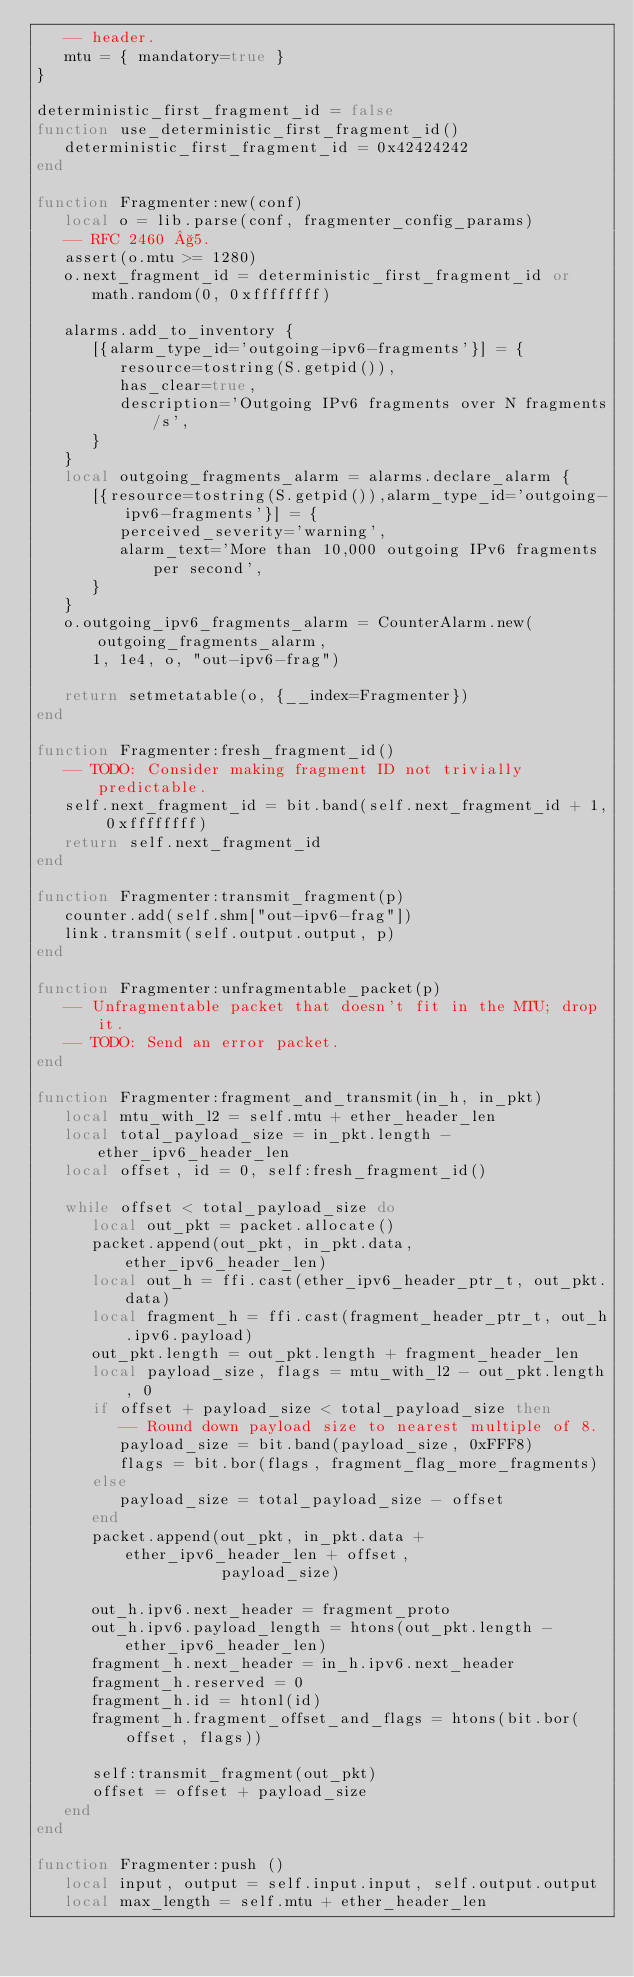<code> <loc_0><loc_0><loc_500><loc_500><_Lua_>   -- header.
   mtu = { mandatory=true }
}

deterministic_first_fragment_id = false
function use_deterministic_first_fragment_id()
   deterministic_first_fragment_id = 0x42424242
end

function Fragmenter:new(conf)
   local o = lib.parse(conf, fragmenter_config_params)
   -- RFC 2460 §5.
   assert(o.mtu >= 1280)
   o.next_fragment_id = deterministic_first_fragment_id or
      math.random(0, 0xffffffff)

   alarms.add_to_inventory {
      [{alarm_type_id='outgoing-ipv6-fragments'}] = {
         resource=tostring(S.getpid()),
         has_clear=true,
         description='Outgoing IPv6 fragments over N fragments/s',
      }
   }
   local outgoing_fragments_alarm = alarms.declare_alarm {
      [{resource=tostring(S.getpid()),alarm_type_id='outgoing-ipv6-fragments'}] = {
         perceived_severity='warning',
         alarm_text='More than 10,000 outgoing IPv6 fragments per second',
      }
   }
   o.outgoing_ipv6_fragments_alarm = CounterAlarm.new(outgoing_fragments_alarm,
      1, 1e4, o, "out-ipv6-frag")

   return setmetatable(o, {__index=Fragmenter})
end

function Fragmenter:fresh_fragment_id()
   -- TODO: Consider making fragment ID not trivially predictable.
   self.next_fragment_id = bit.band(self.next_fragment_id + 1, 0xffffffff)
   return self.next_fragment_id
end

function Fragmenter:transmit_fragment(p)
   counter.add(self.shm["out-ipv6-frag"])
   link.transmit(self.output.output, p)
end

function Fragmenter:unfragmentable_packet(p)
   -- Unfragmentable packet that doesn't fit in the MTU; drop it.
   -- TODO: Send an error packet.
end

function Fragmenter:fragment_and_transmit(in_h, in_pkt)
   local mtu_with_l2 = self.mtu + ether_header_len
   local total_payload_size = in_pkt.length - ether_ipv6_header_len
   local offset, id = 0, self:fresh_fragment_id()

   while offset < total_payload_size do
      local out_pkt = packet.allocate()
      packet.append(out_pkt, in_pkt.data, ether_ipv6_header_len)
      local out_h = ffi.cast(ether_ipv6_header_ptr_t, out_pkt.data)
      local fragment_h = ffi.cast(fragment_header_ptr_t, out_h.ipv6.payload)
      out_pkt.length = out_pkt.length + fragment_header_len
      local payload_size, flags = mtu_with_l2 - out_pkt.length, 0
      if offset + payload_size < total_payload_size then
         -- Round down payload size to nearest multiple of 8.
         payload_size = bit.band(payload_size, 0xFFF8)
         flags = bit.bor(flags, fragment_flag_more_fragments)
      else
         payload_size = total_payload_size - offset
      end
      packet.append(out_pkt, in_pkt.data + ether_ipv6_header_len + offset,
                    payload_size)

      out_h.ipv6.next_header = fragment_proto
      out_h.ipv6.payload_length = htons(out_pkt.length - ether_ipv6_header_len)
      fragment_h.next_header = in_h.ipv6.next_header
      fragment_h.reserved = 0
      fragment_h.id = htonl(id)
      fragment_h.fragment_offset_and_flags = htons(bit.bor(offset, flags))

      self:transmit_fragment(out_pkt)
      offset = offset + payload_size
   end
end

function Fragmenter:push ()
   local input, output = self.input.input, self.output.output
   local max_length = self.mtu + ether_header_len
</code> 